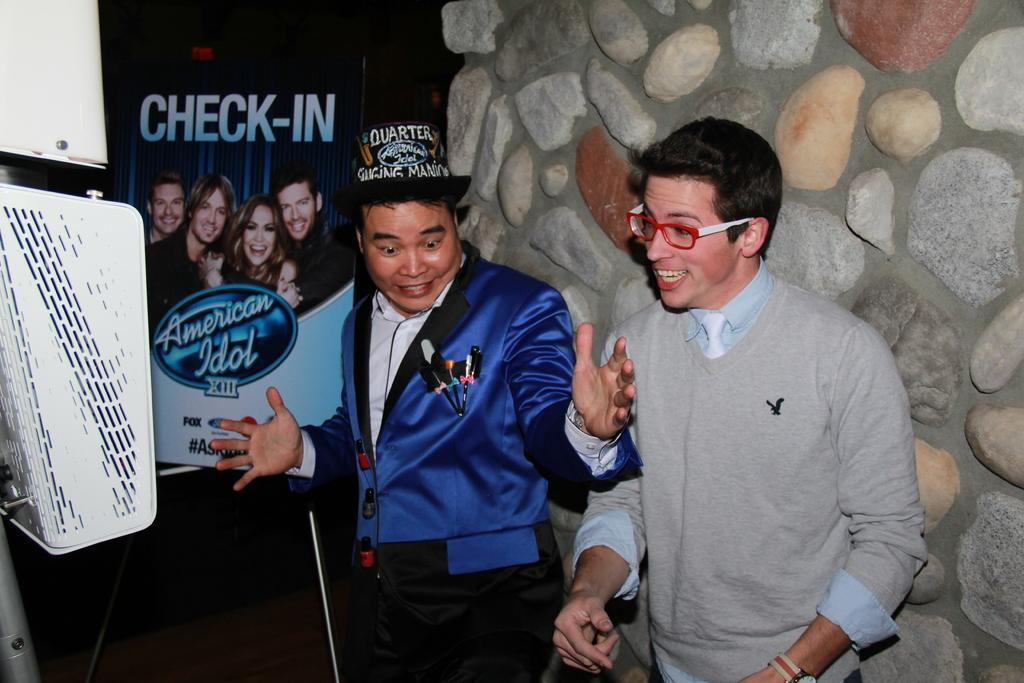How many people are in the image? There are two men standing in the image. What is the facial expression of the men? The men are smiling. What type of advertisement or display might this image be a part of? The image appears to be a hoarding. What color is the object in the image? There is a white object in the image. What can be seen on the wall in the image? There is a wall with rocks in the image. What type of war is depicted in the image? There is no depiction of war in the image; it features two men standing and smiling. How does the behavior of the men in the image affect the outcome of the planes? There are no planes present in the image, and the behavior of the men does not affect any planes. 